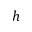Convert formula to latex. <formula><loc_0><loc_0><loc_500><loc_500>h</formula> 